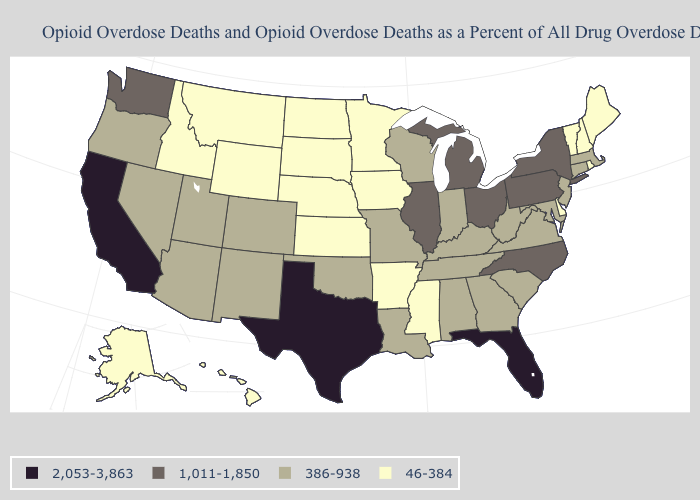Among the states that border California , which have the highest value?
Give a very brief answer. Arizona, Nevada, Oregon. Among the states that border Vermont , does New York have the lowest value?
Give a very brief answer. No. Name the states that have a value in the range 2,053-3,863?
Be succinct. California, Florida, Texas. What is the value of Nevada?
Concise answer only. 386-938. Name the states that have a value in the range 46-384?
Quick response, please. Alaska, Arkansas, Delaware, Hawaii, Idaho, Iowa, Kansas, Maine, Minnesota, Mississippi, Montana, Nebraska, New Hampshire, North Dakota, Rhode Island, South Dakota, Vermont, Wyoming. Which states have the lowest value in the USA?
Be succinct. Alaska, Arkansas, Delaware, Hawaii, Idaho, Iowa, Kansas, Maine, Minnesota, Mississippi, Montana, Nebraska, New Hampshire, North Dakota, Rhode Island, South Dakota, Vermont, Wyoming. Which states have the lowest value in the USA?
Give a very brief answer. Alaska, Arkansas, Delaware, Hawaii, Idaho, Iowa, Kansas, Maine, Minnesota, Mississippi, Montana, Nebraska, New Hampshire, North Dakota, Rhode Island, South Dakota, Vermont, Wyoming. Does Georgia have a higher value than Missouri?
Write a very short answer. No. Among the states that border Iowa , does Wisconsin have the lowest value?
Quick response, please. No. Is the legend a continuous bar?
Answer briefly. No. Which states have the highest value in the USA?
Concise answer only. California, Florida, Texas. Does Colorado have the lowest value in the USA?
Write a very short answer. No. What is the value of Nevada?
Be succinct. 386-938. Which states have the lowest value in the USA?
Concise answer only. Alaska, Arkansas, Delaware, Hawaii, Idaho, Iowa, Kansas, Maine, Minnesota, Mississippi, Montana, Nebraska, New Hampshire, North Dakota, Rhode Island, South Dakota, Vermont, Wyoming. Name the states that have a value in the range 2,053-3,863?
Be succinct. California, Florida, Texas. 